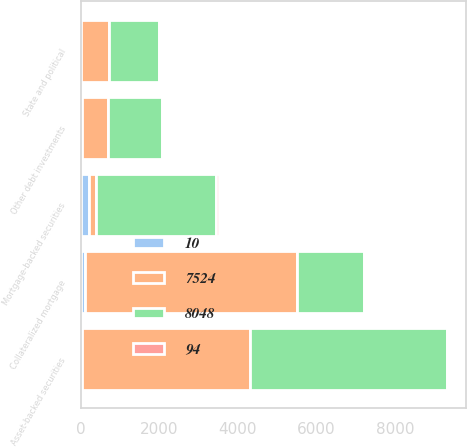Convert chart to OTSL. <chart><loc_0><loc_0><loc_500><loc_500><stacked_bar_chart><ecel><fcel>Mortgage-backed securities<fcel>Asset-backed securities<fcel>Collateralized mortgage<fcel>State and political<fcel>Other debt investments<nl><fcel>8048<fcel>3048<fcel>5038<fcel>1703<fcel>1272<fcel>1382<nl><fcel>94<fcel>66<fcel>7<fcel>9<fcel>6<fcel>9<nl><fcel>7524<fcel>197<fcel>4264<fcel>5400<fcel>703<fcel>665<nl><fcel>10<fcel>197<fcel>33<fcel>111<fcel>5<fcel>14<nl></chart> 